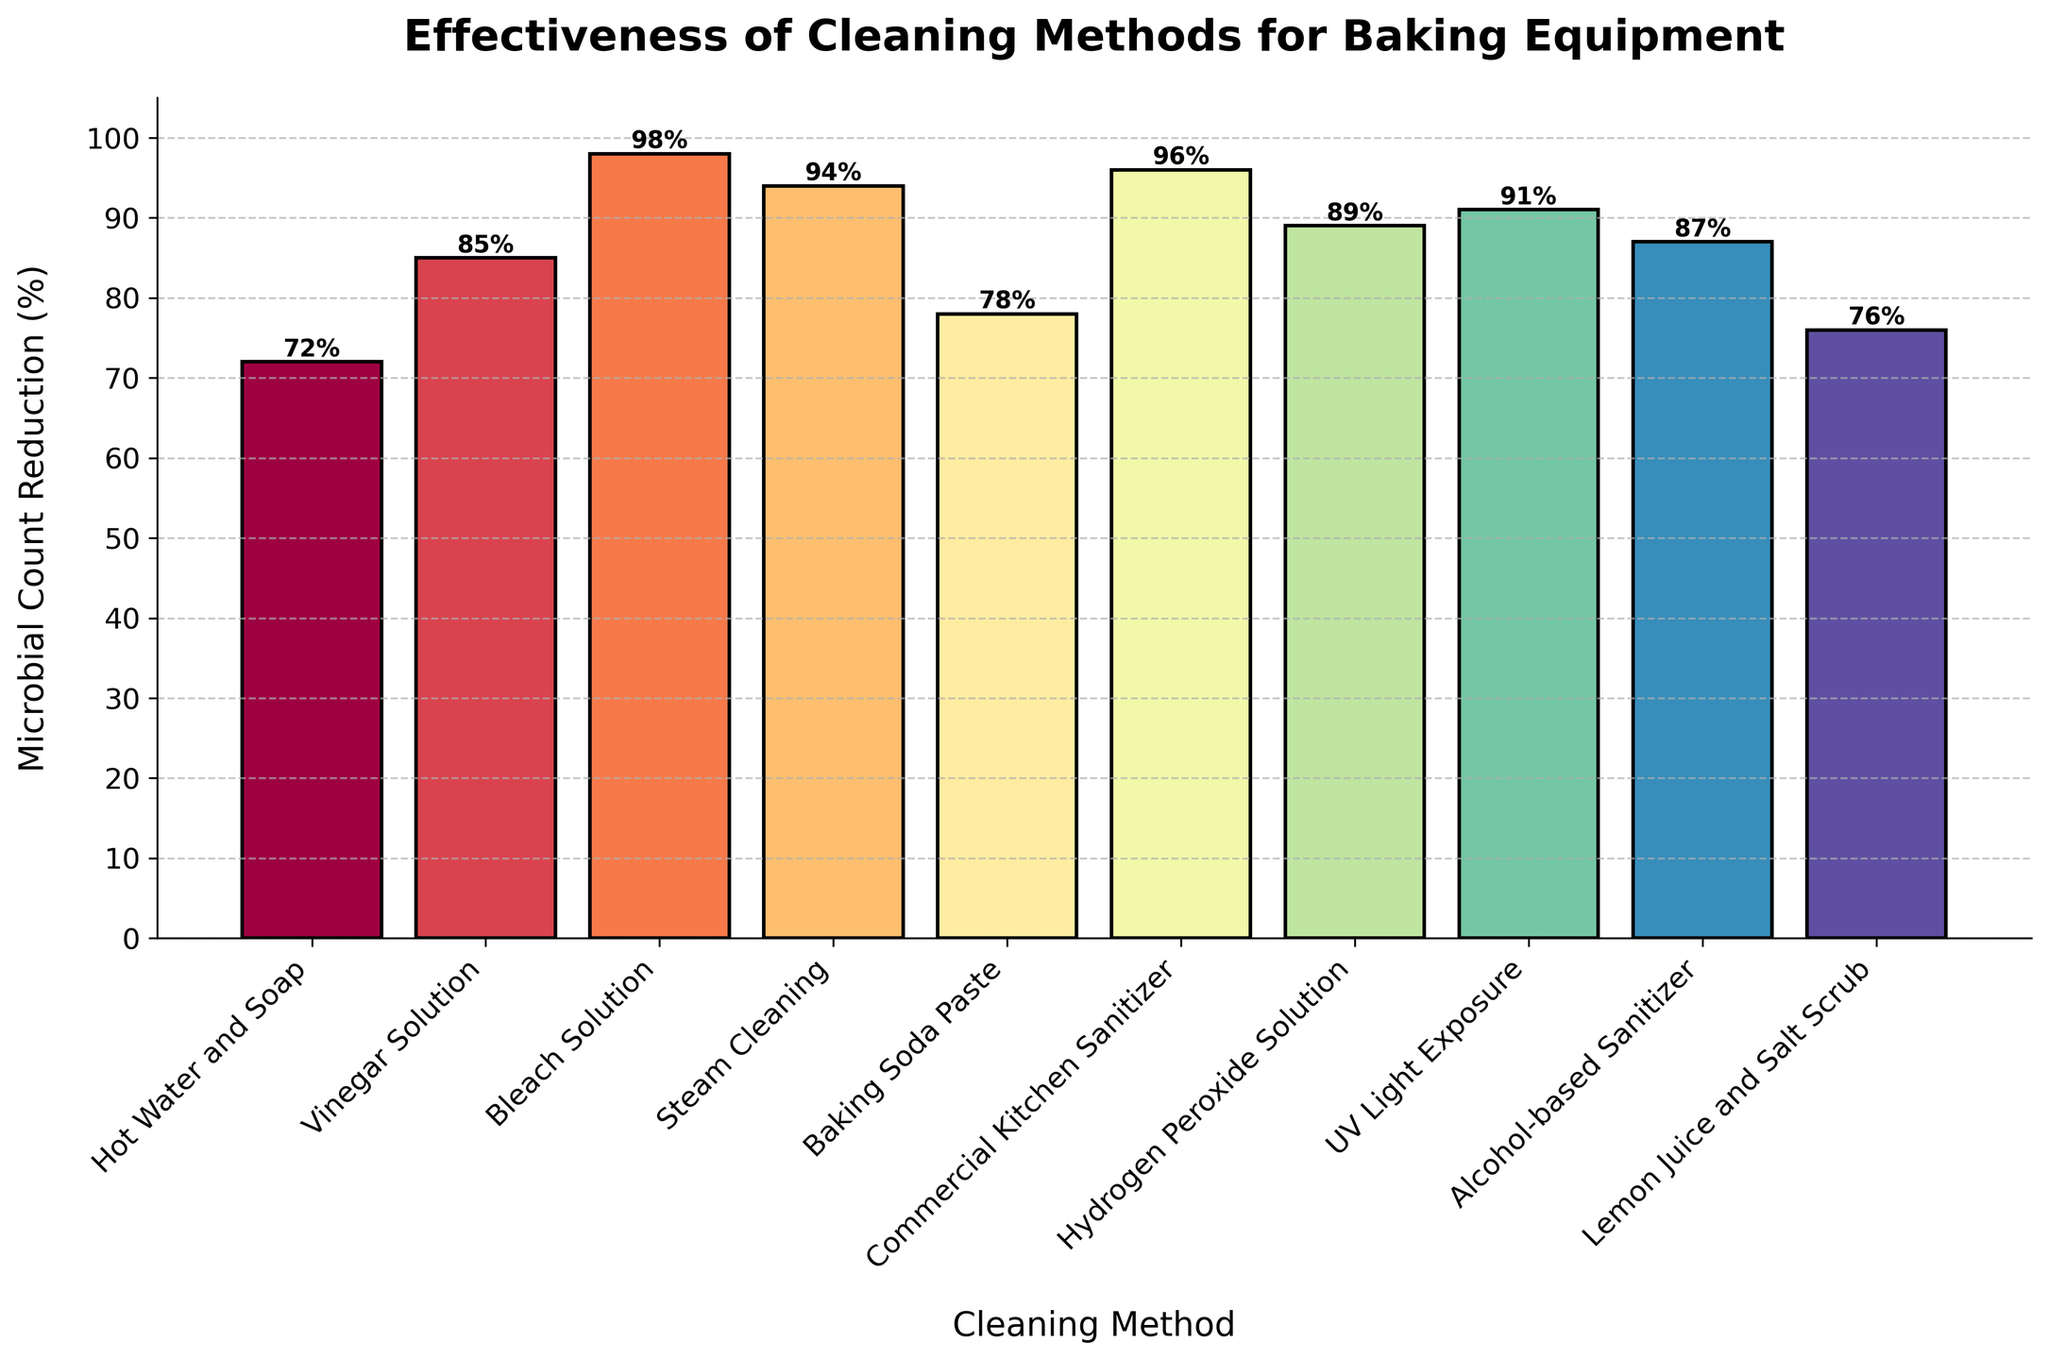Which cleaning method shows the highest reduction in microbial count? Look for the tallest bar in the bar chart. The tallest bar represents the "Bleach Solution" with a 98% reduction in microbial count.
Answer: Bleach Solution Which two cleaning methods have the closest microbial count reduction percentages? Compare the bars' heights to find the two closest ones. "Alcohol-based Sanitizer" and "Hydrogen Peroxide Solution" have similar reductions of 87% and 89% respectively.
Answer: Alcohol-based Sanitizer and Hydrogen Peroxide Solution What is the difference in microbial count reduction between the Commercial Kitchen Sanitizer and the Baking Soda Paste? Check the heights of the bars for "Commercial Kitchen Sanitizer" (96%) and "Baking Soda Paste" (78%). Calculate the difference: 96% - 78% = 18%.
Answer: 18% List the cleaning methods that have a reduction exceeding 90%. Identify bars with heights greater than 90%. The methods are "Bleach Solution" (98%), "Steam Cleaning" (94%), "Commercial Kitchen Sanitizer" (96%), "UV Light Exposure" (91%), and "Hydrogen Peroxide Solution" (89%).
Answer: Bleach Solution, Steam Cleaning, Commercial Kitchen Sanitizer, UV Light Exposure What is the average microbial count reduction for all cleaning methods? Sum the reductions and divide by the number of methods: (72 + 85 + 98 + 94 + 78 + 96 + 89 + 91 + 87 + 76) / 10 = 86.6%.
Answer: 86.6% Compare the effectiveness of Vinegar Solution and Lemon Juice and Salt Scrub. Which is more effective and by how much? Identify the reductions for "Vinegar Solution" (85%) and "Lemon Juice and Salt Scrub" (76%). Subtract the lower percentage from the higher: 85% - 76% = 9%. Vinegar Solution is more effective by 9%.
Answer: Vinegar Solution by 9% What is the range of microbial count reductions shown in the chart? Find the difference between the maximum and minimum values in the chart. The maximum reduction is 98% (Bleach Solution) and the minimum is 72% (Hot Water and Soap). The range is 98% - 72% = 26%.
Answer: 26% Which cleaning methods show reductions within the range of 70% to 80%? Check the heights of the bars falling between 70% and 80%. The methods are "Hot Water and Soap" (72%), "Baking Soda Paste" (78%), and "Lemon Juice and Salt Scrub" (76%).
Answer: Hot Water and Soap, Baking Soda Paste, Lemon Juice and Salt Scrub How many cleaning methods have a microbial count reduction equal to or greater than 85%? Count the methods where the bars' heights are 85% or above. The methods are "Vinegar Solution" (85%), "Bleach Solution" (98%), "Steam Cleaning" (94%), "Commercial Kitchen Sanitizer" (96%), "Hydrogen Peroxide Solution" (89%), UV Light Exposure (91%), and "Alcohol-based Sanitizer" (87%) - totaling 7 methods.
Answer: 7 